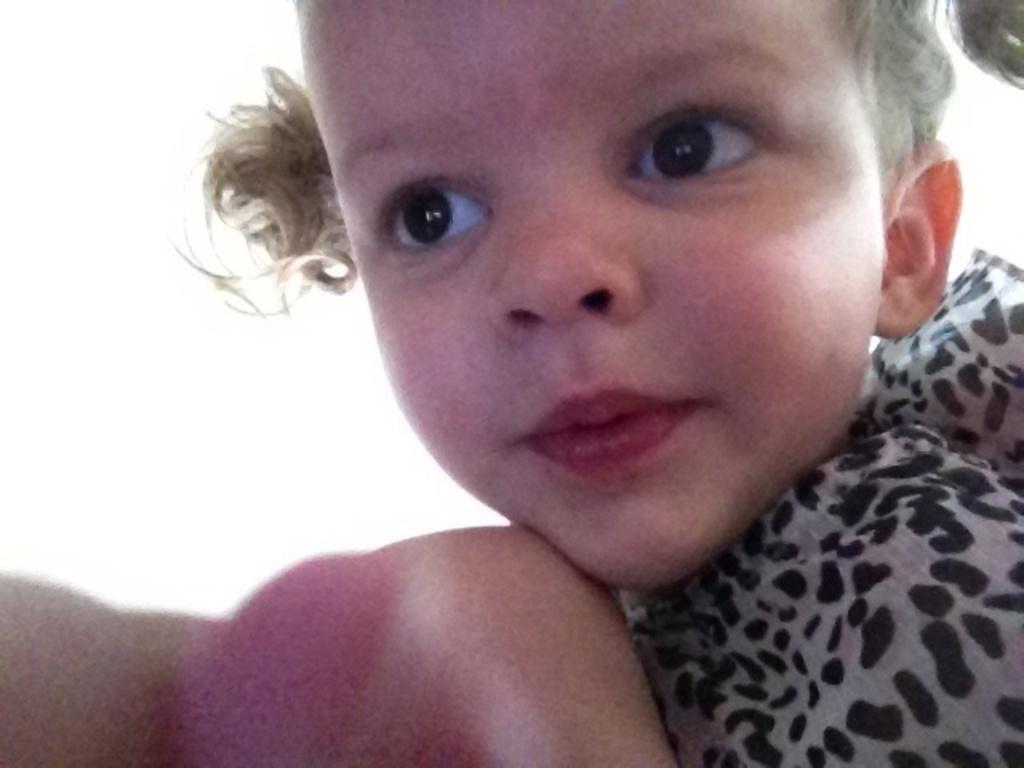Can you describe this image briefly? In this image I can see the person wearing the black and ash color dress. And there is a white background. 